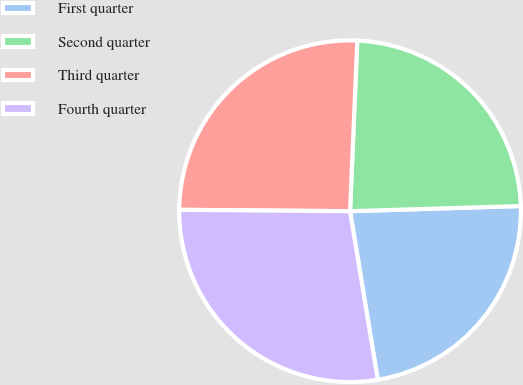Convert chart to OTSL. <chart><loc_0><loc_0><loc_500><loc_500><pie_chart><fcel>First quarter<fcel>Second quarter<fcel>Third quarter<fcel>Fourth quarter<nl><fcel>22.89%<fcel>23.84%<fcel>25.55%<fcel>27.73%<nl></chart> 